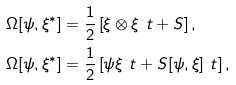<formula> <loc_0><loc_0><loc_500><loc_500>\Omega [ \psi , \xi ^ { * } ] & = \frac { 1 } { 2 } \left [ \xi \otimes \xi ^ { \ } t + S \right ] , \\ \Omega [ \psi , \xi ^ { * } ] & = \frac { 1 } { 2 } \left [ \psi \xi ^ { \ } t + S [ \psi , \xi ] ^ { \ } t \right ] ,</formula> 